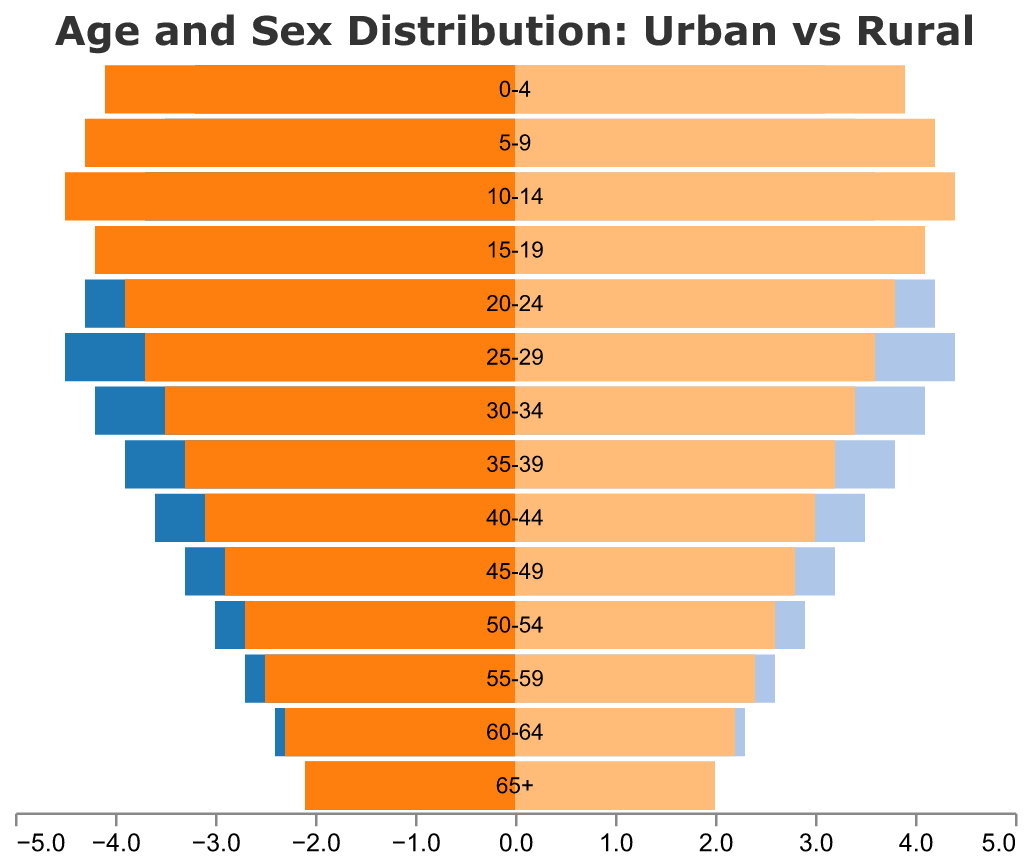What is the title of the figure? The title of the figure is shown at the top of the plot.
Answer: Age and Sex Distribution: Urban vs Rural Which age group has the highest population of Rural Males? By examining the lengths of the bars for Rural Males, we see that the age group 10-14 has the highest value.
Answer: 10-14 How do the populations of Urban Males and Rural Males in the age group 25-29 compare? The plot shows that the Urban Male population is greater than the Rural Male population for the age group 25-29. The Urban Male bar extends to -4.5 while the Rural Male bar extends to -3.7.
Answer: Urban Male population is higher What is the population difference between Urban Females and Rural Females in the age group 55-59? By looking at the lengths of the bars for Urban Females and Rural Females in the age group 55-59, Urban Females is 2.6 and Rural Females is 2.4. Subtracting these gives 2.6 - 2.4 = 0.2.
Answer: 0.2 What can you observe about the overall trend in male populations moving from younger to older age groups? As we move from younger to older age groups, the populations of both Urban and Rural Males generally decrease. This trend is shown by the gradually shorter bars for both Urban and Rural Males as the age group increases.
Answer: Populations generally decrease How does the population distribution differ between Urban and Rural environments for the age group 0-4? The plot shows that there are more Rural Males and Rural Females than Urban Males and Urban Females in the age group 0-4. Rural Males have a value of 4.1 and Rural Females have 3.9, while Urban Males have 3.2 and Urban Females have 3.1.
Answer: More population in Rural Which environment has a higher proportion of their overall population in the age group 20-24? By comparing the bar lengths for both Urban and Rural in the age group 20-24, we observe that the Urban population (both males and females) have higher values (4.3 and 4.2) than the Rural population (3.9 and 3.8).
Answer: Urban What is the population ratio of Urban Males to Urban Females in the age group 40-44? Urban Males in the age group 40-44 have a population of 3.6, and Urban Females have 3.5. The ratio is calculated as 3.6 / 3.5.
Answer: Approximately 1.03 Identify the age group where the Rural Female population equals the Urban Female population. By examining the lengths of the bars for Urban and Rural Females, we see that in the age group 65+, both Urban and Rural Female populations are equal to 2.0.
Answer: 65+ How does the age distribution for Urban Females compare to Rural Females across all age groups? For most age groups, Urban Female populations are slightly lower than Rural Female populations, except for the 20-24 and 25-29 age groups where Urban Females exceed Rural Females.
Answer: Urban Females are generally lower except for age groups 20-24 and 25-29 